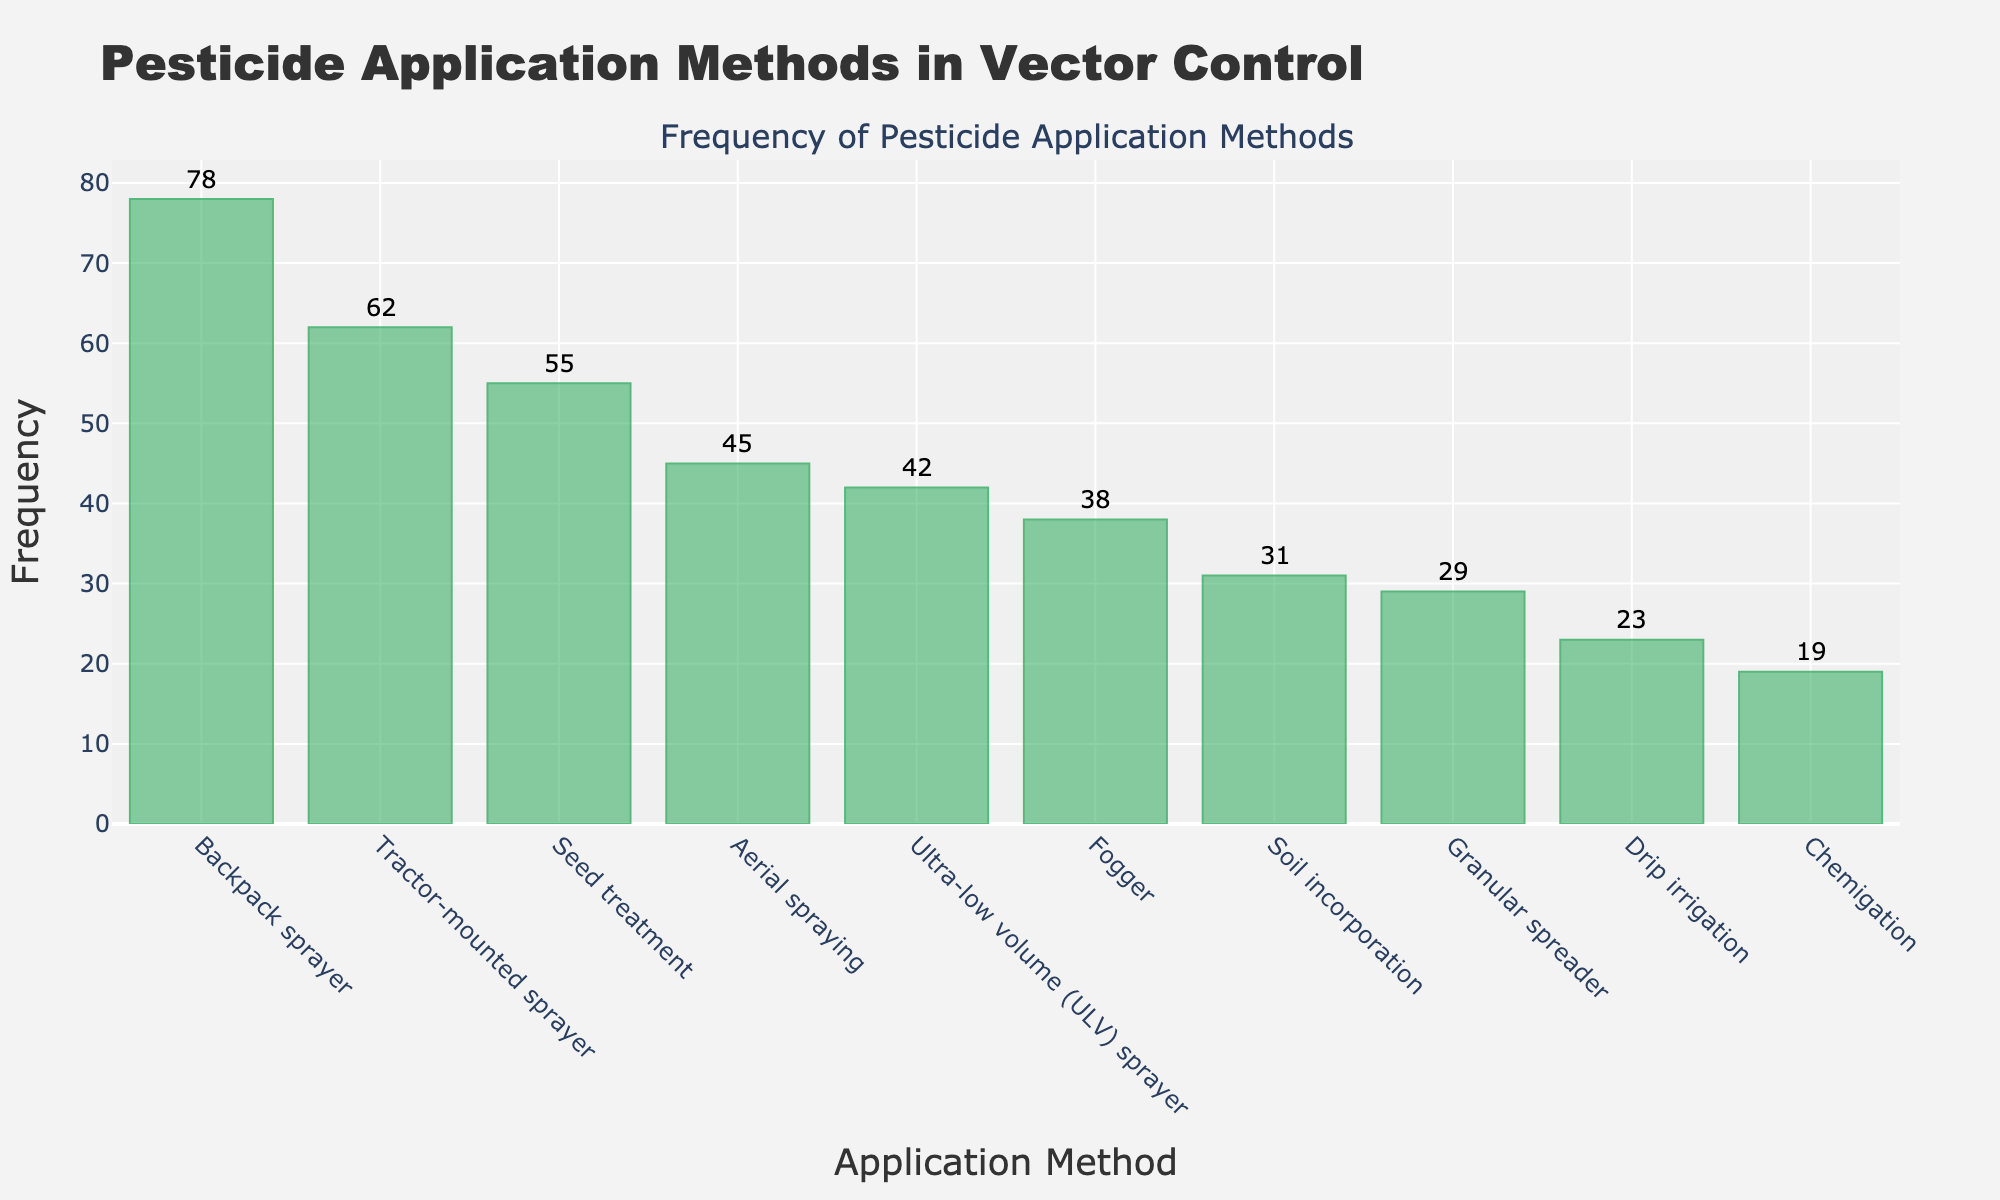what is the title of the histogram? The title is usually located at the top of the histogram and it provides the main topic or focus of the chart. Look at the top center of the figure.
Answer: Pesticide Application Methods in Vector Control how many application methods are depicted in the histogram? Count the number of bars in the histogram to determine the number of different application methods.
Answer: 10 which pesticide application method is used most frequently? Identify the tallest bar in the histogram since the height represents the frequency of usage.
Answer: Backpack sprayer which pesticide application method has the lowest frequency? Find the shortest bar in the histogram as it represents the least frequent application method.
Answer: Chemigation what is the combined frequency of Tractor-mounted sprayer and Seed treatment application methods? Sum the frequency values for both methods. The frequencies are 62 and 55, respectively.
Answer: 117 how does the frequency of Aerial spraying compare to Fogger? Compare the heights of the bars for Aerial spraying and Fogger.
Answer: Aerial spraying is more frequent what is the difference in frequency between the most and least used pesticide application methods? Subtract the frequency of the least used method (Chemigation) from the most used method (Backpack sprayer).
Answer: 59 what is the total frequency of all application methods combined? Add up the frequencies of all application methods provided.
Answer: 422 which application methods have frequencies higher than 50? Identify the bars that have heights representing frequencies greater than 50.
Answer: Aerial spraying, Backpack sprayer, Tractor-mounted sprayer, and Seed treatment what is the average frequency of all application methods? Sum all the frequencies and divide by the number of application methods. First, calculate the sum 422 and then divide by 10.
Answer: 42.2 